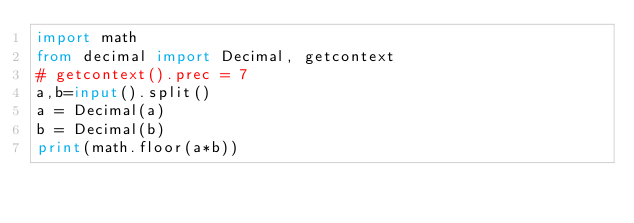Convert code to text. <code><loc_0><loc_0><loc_500><loc_500><_Python_>import math
from decimal import Decimal, getcontext
# getcontext().prec = 7
a,b=input().split()
a = Decimal(a)
b = Decimal(b)
print(math.floor(a*b))</code> 